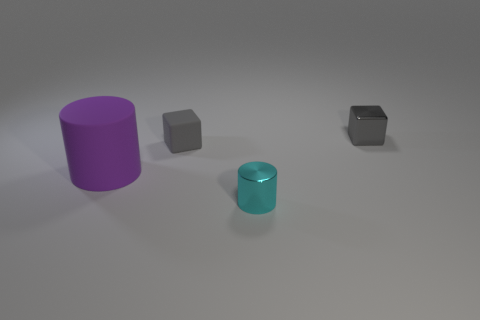There is another cube that is the same color as the shiny cube; what is its size?
Your answer should be very brief. Small. What is the shape of the small thing that is the same color as the metallic block?
Offer a terse response. Cube. Is there anything else that has the same color as the metal cylinder?
Your answer should be very brief. No. How many other objects are the same material as the large cylinder?
Your response must be concise. 1. The metal cylinder has what size?
Make the answer very short. Small. Are there any small rubber objects that have the same shape as the large rubber thing?
Keep it short and to the point. No. What number of objects are metal cylinders or small gray things right of the cyan cylinder?
Provide a succinct answer. 2. What color is the tiny block in front of the tiny metal cube?
Give a very brief answer. Gray. There is a gray cube that is on the right side of the tiny cyan shiny cylinder; does it have the same size as the rubber thing that is behind the big purple rubber object?
Give a very brief answer. Yes. Are there any blue matte balls of the same size as the cyan cylinder?
Provide a succinct answer. No. 